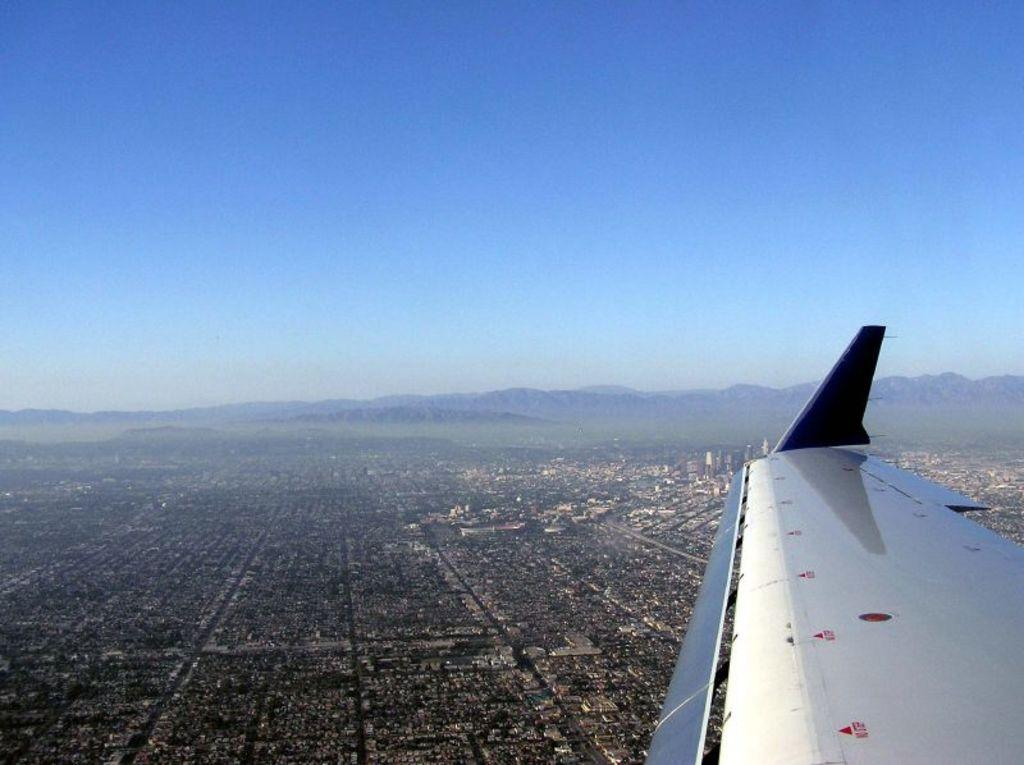What type of view is shown in the image? The image is an aerial view. What structures can be seen in the aerial view? There are buildings in the aerial view. What natural elements are present in the aerial view? There are trees and hills in the aerial view. What part of the natural environment is visible in the aerial view? The sky is visible in the aerial view. What is the source of the aerial view? There is an aircraft in the air. What type of pie is being served on the hill in the image? There is no pie present in the image; it is an aerial view of buildings, trees, hills, and sky. What type of animal can be seen grazing on the grass in the image? There are no animals visible in the image; it is an aerial view of buildings, trees, hills, and sky. 